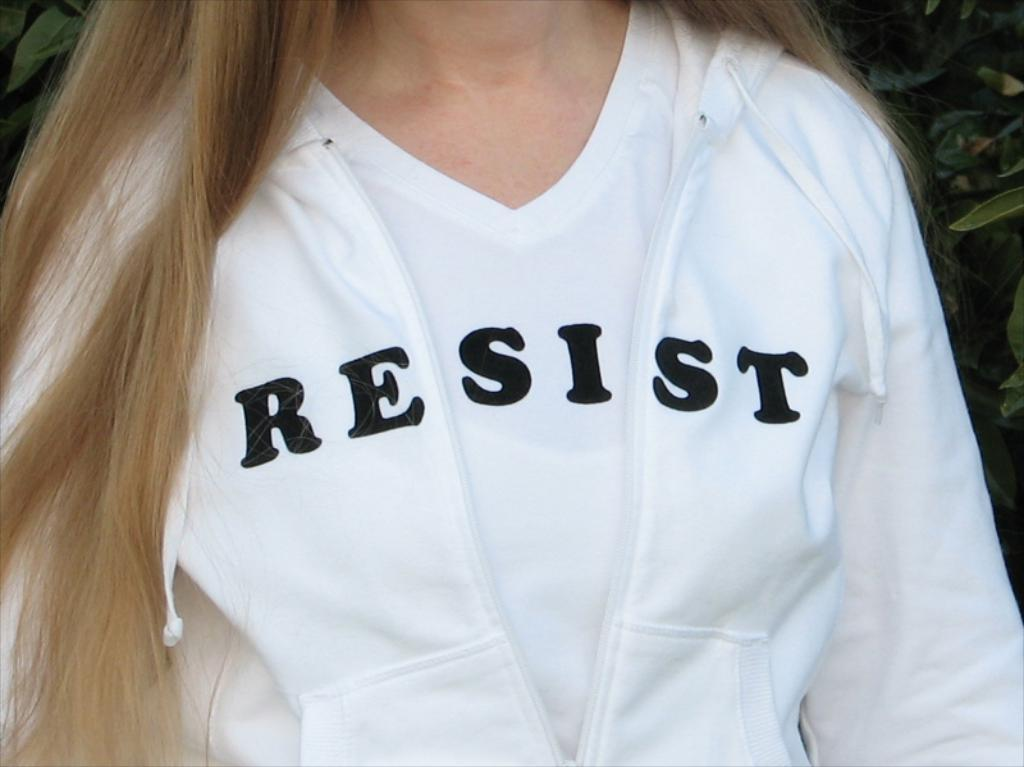<image>
Give a short and clear explanation of the subsequent image. A woman wears a shirt with the word resist on it in black. 